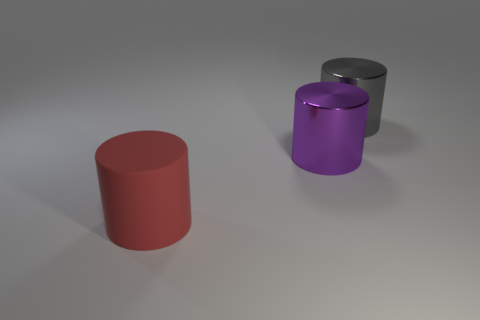Is there anything else that is the same material as the red cylinder?
Offer a very short reply. No. What number of green shiny spheres are there?
Your answer should be compact. 0. What number of cylinders are both behind the red thing and in front of the purple cylinder?
Make the answer very short. 0. Are there any big red objects made of the same material as the big purple thing?
Offer a very short reply. No. There is a purple thing that is in front of the metal cylinder that is behind the purple cylinder; what is its material?
Provide a short and direct response. Metal. Are there the same number of large purple objects that are on the right side of the gray shiny cylinder and large red things that are on the right side of the purple cylinder?
Keep it short and to the point. Yes. Does the purple object have the same shape as the gray metallic object?
Your response must be concise. Yes. The object that is left of the big gray cylinder and behind the large red matte cylinder is made of what material?
Give a very brief answer. Metal. How many gray shiny objects have the same shape as the big purple object?
Your response must be concise. 1. There is a metal cylinder that is on the left side of the big cylinder to the right of the large metal cylinder on the left side of the large gray shiny cylinder; what size is it?
Offer a terse response. Large. 